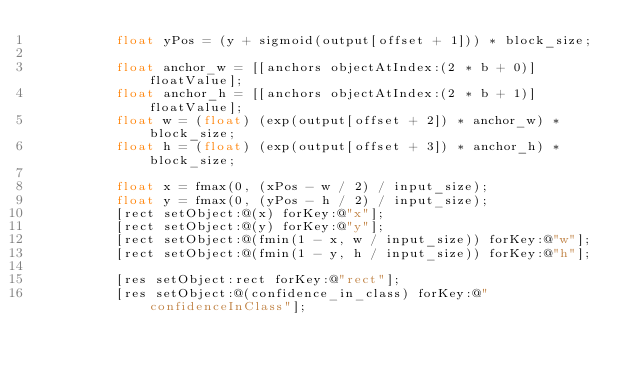Convert code to text. <code><loc_0><loc_0><loc_500><loc_500><_ObjectiveC_>          float yPos = (y + sigmoid(output[offset + 1])) * block_size;
          
          float anchor_w = [[anchors objectAtIndex:(2 * b + 0)] floatValue];
          float anchor_h = [[anchors objectAtIndex:(2 * b + 1)] floatValue];
          float w = (float) (exp(output[offset + 2]) * anchor_w) * block_size;
          float h = (float) (exp(output[offset + 3]) * anchor_h) * block_size;
          
          float x = fmax(0, (xPos - w / 2) / input_size);
          float y = fmax(0, (yPos - h / 2) / input_size);
          [rect setObject:@(x) forKey:@"x"];
          [rect setObject:@(y) forKey:@"y"];
          [rect setObject:@(fmin(1 - x, w / input_size)) forKey:@"w"];
          [rect setObject:@(fmin(1 - y, h / input_size)) forKey:@"h"];
          
          [res setObject:rect forKey:@"rect"];
          [res setObject:@(confidence_in_class) forKey:@"confidenceInClass"];</code> 